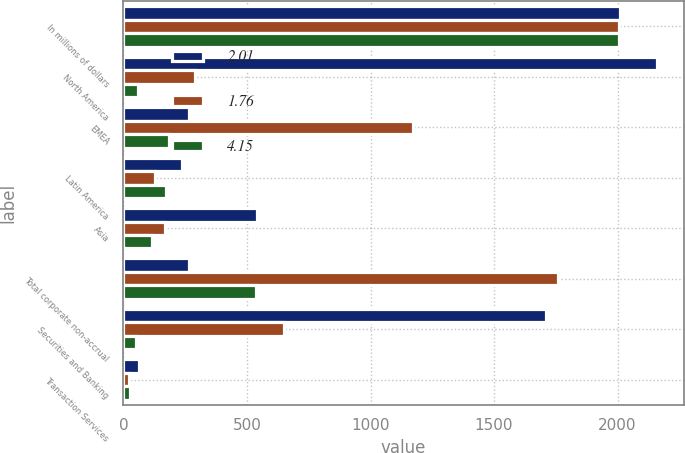Convert chart to OTSL. <chart><loc_0><loc_0><loc_500><loc_500><stacked_bar_chart><ecel><fcel>In millions of dollars<fcel>North America<fcel>EMEA<fcel>Latin America<fcel>Asia<fcel>Total corporate non-accrual<fcel>Securities and Banking<fcel>Transaction Services<nl><fcel>2.01<fcel>2008<fcel>2160<fcel>264<fcel>238<fcel>541<fcel>264<fcel>1711<fcel>62<nl><fcel>1.76<fcel>2007<fcel>290<fcel>1173<fcel>127<fcel>168<fcel>1758<fcel>649<fcel>24<nl><fcel>4.15<fcel>2006<fcel>59<fcel>186<fcel>173<fcel>117<fcel>535<fcel>49<fcel>27<nl></chart> 